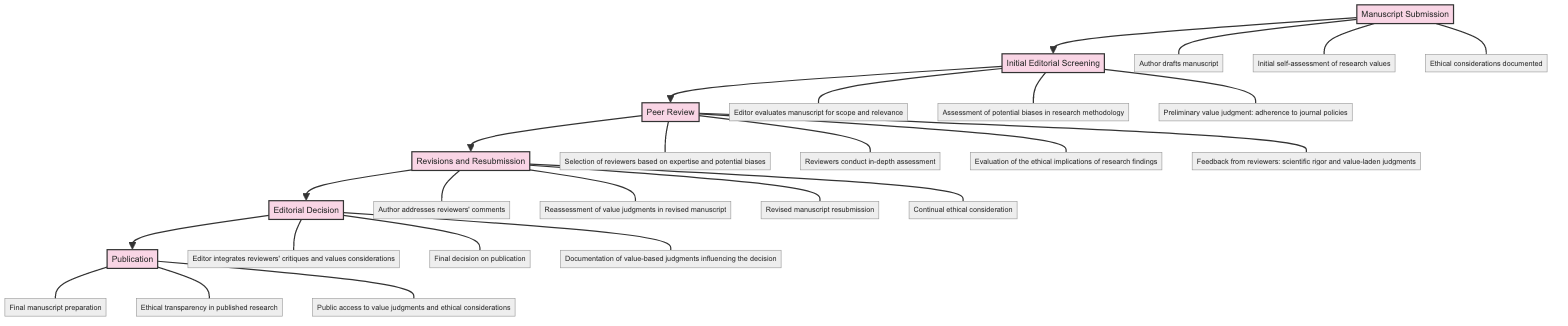What's the first stage in the peer review process? The diagram starts with the first stage labeled "Manuscript Submission," which is the initial step in the peer review process.
Answer: Manuscript Submission How many activities are in the "Peer Review" stage? In the "Peer Review" stage, there are four listed activities: selection of reviewers, in-depth assessment, evaluation of ethical implications, and feedback from reviewers.
Answer: 4 What is the last activity in the "Publication" stage? The last activity listed in the "Publication" stage is "Public access to value judgments and ethical considerations," indicating it is the final step in this process.
Answer: Public access to value judgments and ethical considerations Which stage includes the "Ethical considerations documented" activity? The "Ethical considerations documented" activity is part of the "Manuscript Submission" stage, as indicated by the connection in the diagram.
Answer: Manuscript Submission What relationship exists between "Initial Editorial Screening" and "Peer Review"? The "Initial Editorial Screening" stage directly flows into the "Peer Review" stage, showing a sequential relationship where the initial review leads to peer evaluation.
Answer: Sequential flow What does the "Editorial Decision" stage determine? The "Editorial Decision" stage determines the final decision on publication, implying that the editor reviews all previous critiques and value judgments to reach this conclusion.
Answer: Final decision on publication How many total stages are involved in the peer review process according to the diagram? The diagram outlines six distinct stages from "Manuscript Submission" to "Publication," thereby showing the entirety of the peer review process.
Answer: 6 Which activity in the "Revisions and Resubmission" stage involves continual consideration? The activity "Continual ethical consideration" in the "Revisions and Resubmission" stage implies that ethics remain an ongoing aspect that the author must address during revisions.
Answer: Continual ethical consideration What is documented in the "Editorial Decision" stage? In the "Editorial Decision" stage, the diagram states that "Documentation of value-based judgments influencing the decision" is performed, indicating that the editor keeps a record of how values shaped the publication process.
Answer: Documentation of value-based judgments influencing the decision 